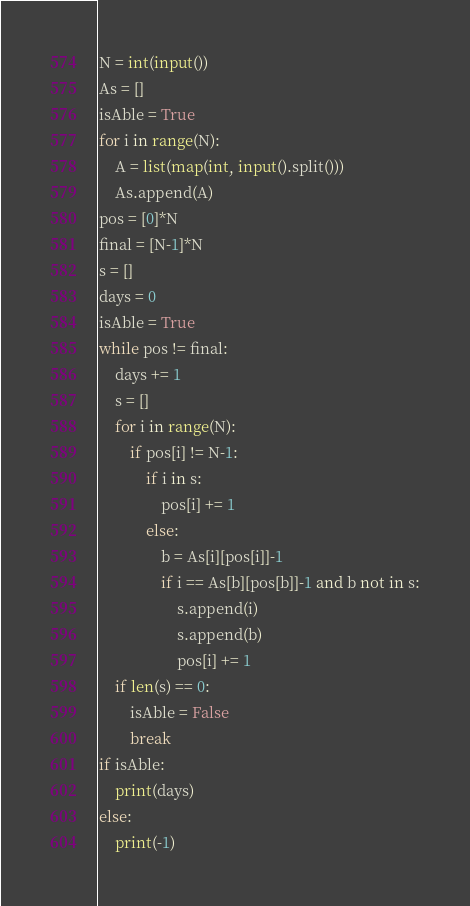<code> <loc_0><loc_0><loc_500><loc_500><_Python_>N = int(input())
As = []
isAble = True
for i in range(N):
    A = list(map(int, input().split()))
    As.append(A)
pos = [0]*N
final = [N-1]*N
s = []
days = 0
isAble = True
while pos != final:
    days += 1
    s = []
    for i in range(N):
        if pos[i] != N-1:
            if i in s:
                pos[i] += 1
            else:
                b = As[i][pos[i]]-1
                if i == As[b][pos[b]]-1 and b not in s:
                    s.append(i)
                    s.append(b)
                    pos[i] += 1
    if len(s) == 0:
        isAble = False
        break
if isAble:
    print(days)
else:
    print(-1)</code> 